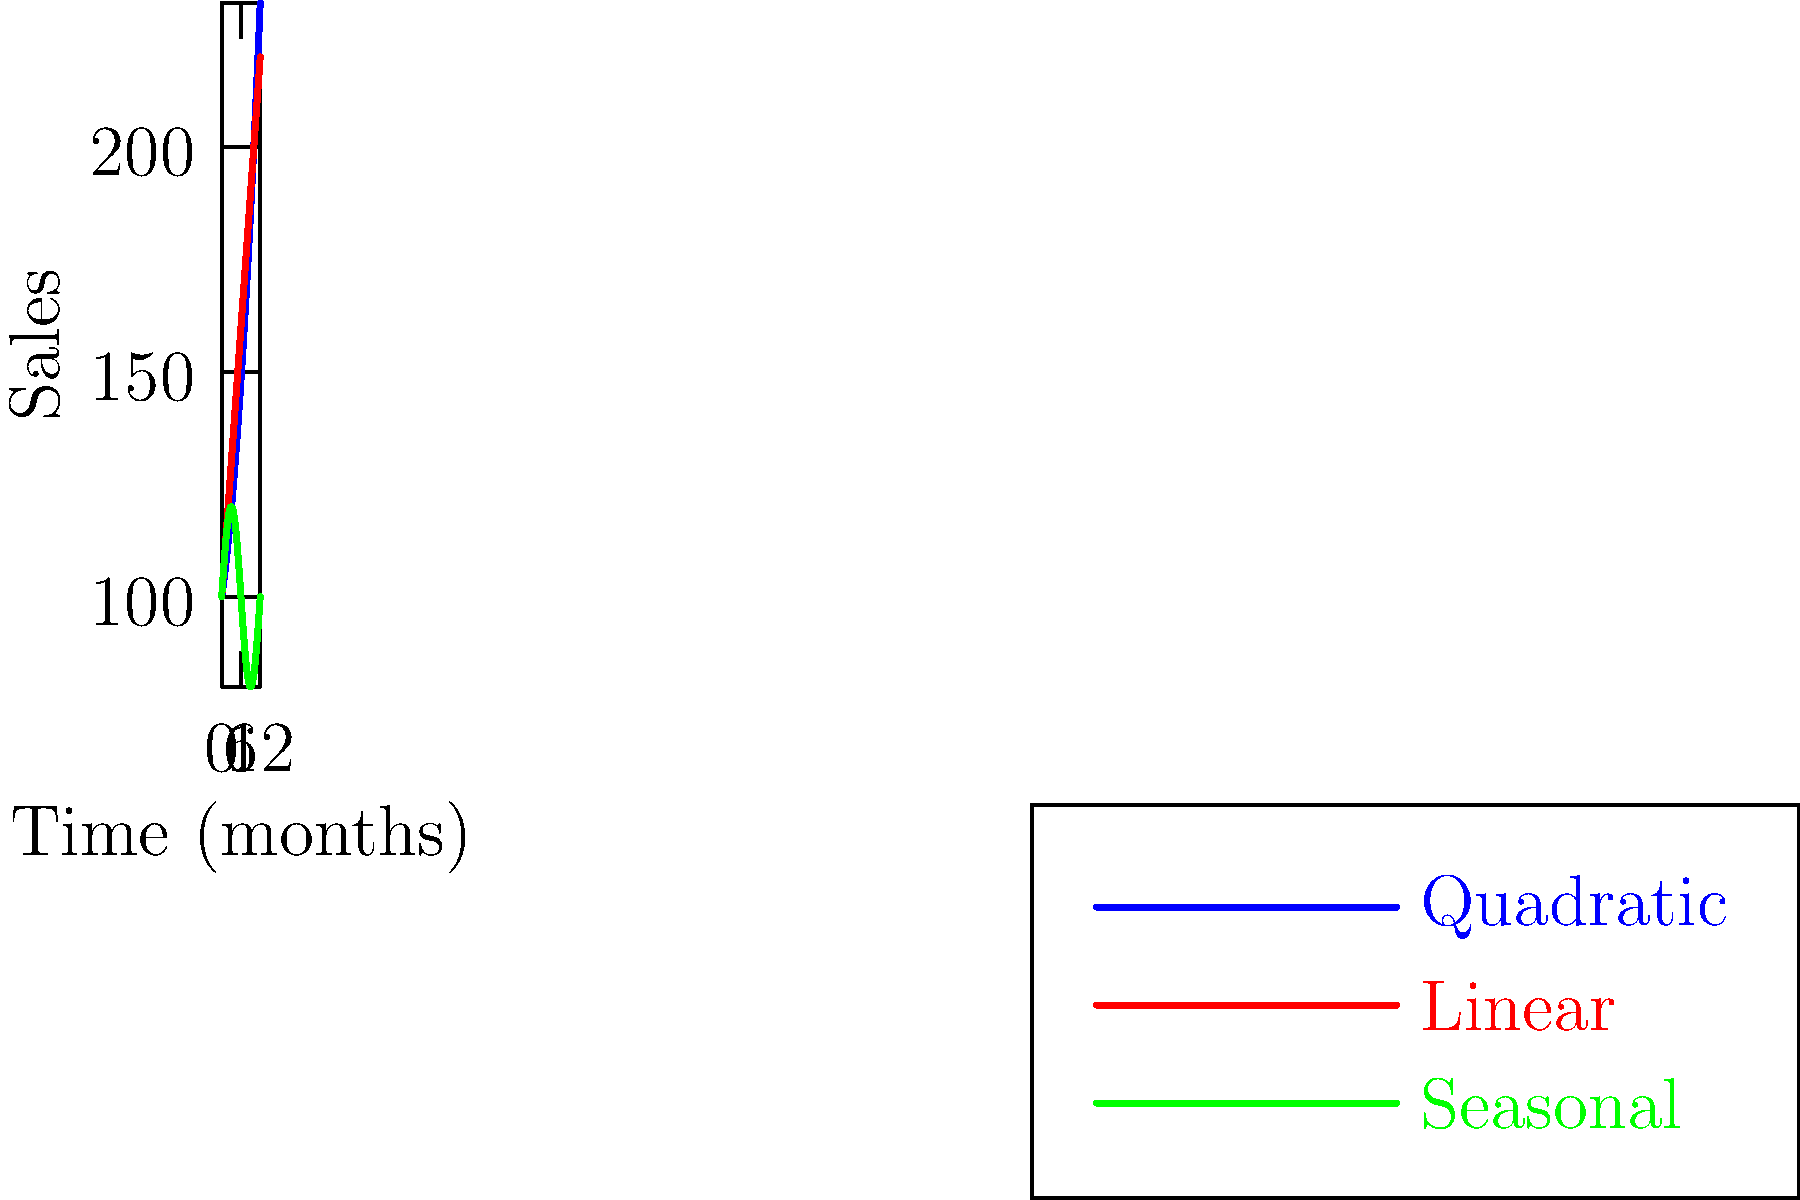The graph shows three different time series forecasting models for monthly sales data over a year. Which model would you recommend for predicting sales in the upcoming months, and why? To determine the most suitable model, we need to analyze each model's characteristics and how they fit the data:

1. Blue line (Quadratic model):
   - Shows an accelerating upward trend
   - Equation: $y = a + bx + cx^2$
   - Captures non-linear growth

2. Red line (Linear model):
   - Shows a constant upward trend
   - Equation: $y = a + bx$
   - Simplest model, assumes constant growth rate

3. Green line (Seasonal model):
   - Shows regular fluctuations
   - Equation: $y = a + b \sin(\frac{\pi x}{6})$
   - Captures cyclical patterns repeating every 12 months

To choose the best model:
1. Check for seasonality: The green line suggests clear seasonal patterns.
2. Assess trend: There's an overall upward trend, but it's not clear if it's linear or accelerating.
3. Consider complexity: The quadratic model might overfit for long-term forecasts.
4. Evaluate business context: Seasonal fluctuations are common in many industries.

Given the clear seasonal pattern and the general upward trend, a combination of the seasonal and linear models would likely be most effective. This approach is known as a seasonal trend model:

$y = a + bx + c \sin(\frac{\pi x}{6})$

This model captures both the overall trend and the seasonal fluctuations, providing a balance between simplicity and accuracy for forecasting future sales.
Answer: Seasonal trend model (combining linear trend and seasonal components) 